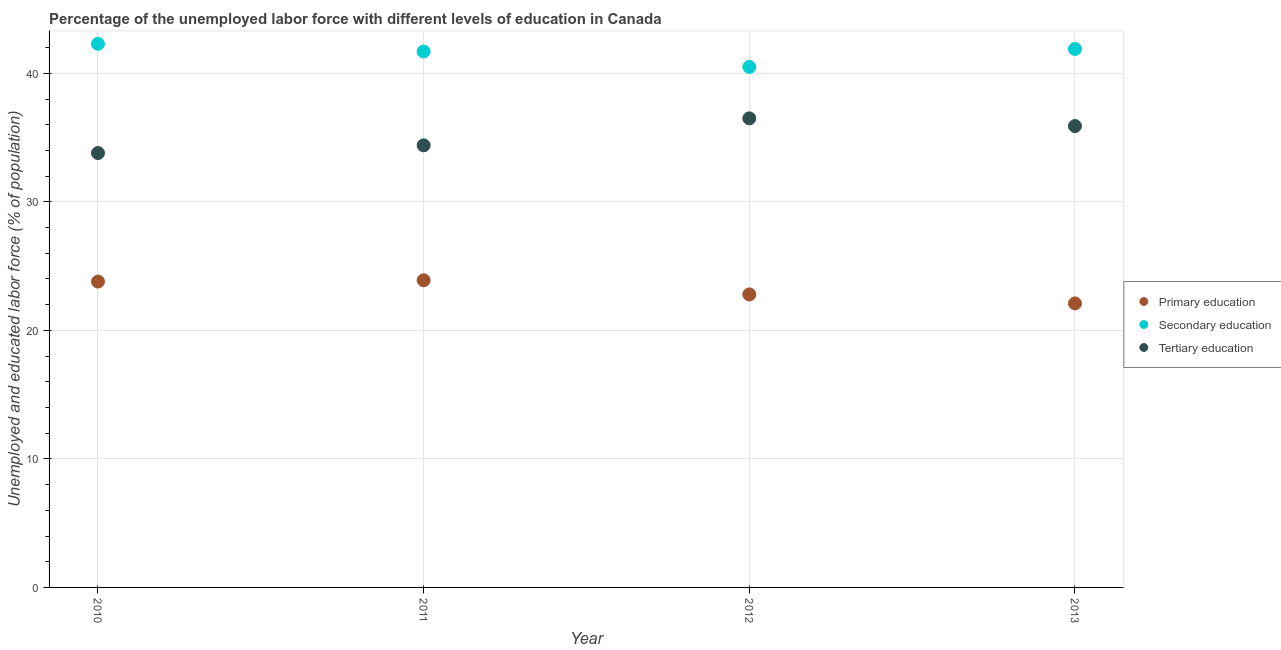What is the percentage of labor force who received secondary education in 2011?
Your response must be concise. 41.7. Across all years, what is the maximum percentage of labor force who received tertiary education?
Make the answer very short. 36.5. Across all years, what is the minimum percentage of labor force who received tertiary education?
Give a very brief answer. 33.8. In which year was the percentage of labor force who received primary education minimum?
Give a very brief answer. 2013. What is the total percentage of labor force who received tertiary education in the graph?
Provide a succinct answer. 140.6. What is the difference between the percentage of labor force who received tertiary education in 2011 and that in 2013?
Provide a short and direct response. -1.5. What is the difference between the percentage of labor force who received tertiary education in 2011 and the percentage of labor force who received primary education in 2013?
Ensure brevity in your answer.  12.3. What is the average percentage of labor force who received primary education per year?
Your answer should be very brief. 23.15. In the year 2011, what is the difference between the percentage of labor force who received secondary education and percentage of labor force who received tertiary education?
Give a very brief answer. 7.3. What is the ratio of the percentage of labor force who received secondary education in 2011 to that in 2013?
Give a very brief answer. 1. Is the percentage of labor force who received tertiary education in 2011 less than that in 2013?
Ensure brevity in your answer.  Yes. What is the difference between the highest and the second highest percentage of labor force who received secondary education?
Your answer should be compact. 0.4. What is the difference between the highest and the lowest percentage of labor force who received primary education?
Keep it short and to the point. 1.8. In how many years, is the percentage of labor force who received secondary education greater than the average percentage of labor force who received secondary education taken over all years?
Your response must be concise. 3. Is the percentage of labor force who received secondary education strictly greater than the percentage of labor force who received tertiary education over the years?
Keep it short and to the point. Yes. Is the percentage of labor force who received tertiary education strictly less than the percentage of labor force who received primary education over the years?
Provide a succinct answer. No. Does the graph contain grids?
Your answer should be very brief. Yes. Where does the legend appear in the graph?
Offer a very short reply. Center right. How many legend labels are there?
Your answer should be compact. 3. What is the title of the graph?
Offer a very short reply. Percentage of the unemployed labor force with different levels of education in Canada. Does "Capital account" appear as one of the legend labels in the graph?
Your answer should be compact. No. What is the label or title of the Y-axis?
Provide a succinct answer. Unemployed and educated labor force (% of population). What is the Unemployed and educated labor force (% of population) in Primary education in 2010?
Your answer should be compact. 23.8. What is the Unemployed and educated labor force (% of population) in Secondary education in 2010?
Your answer should be compact. 42.3. What is the Unemployed and educated labor force (% of population) in Tertiary education in 2010?
Provide a short and direct response. 33.8. What is the Unemployed and educated labor force (% of population) of Primary education in 2011?
Provide a succinct answer. 23.9. What is the Unemployed and educated labor force (% of population) of Secondary education in 2011?
Your answer should be compact. 41.7. What is the Unemployed and educated labor force (% of population) in Tertiary education in 2011?
Provide a short and direct response. 34.4. What is the Unemployed and educated labor force (% of population) in Primary education in 2012?
Offer a terse response. 22.8. What is the Unemployed and educated labor force (% of population) of Secondary education in 2012?
Ensure brevity in your answer.  40.5. What is the Unemployed and educated labor force (% of population) in Tertiary education in 2012?
Your answer should be compact. 36.5. What is the Unemployed and educated labor force (% of population) in Primary education in 2013?
Keep it short and to the point. 22.1. What is the Unemployed and educated labor force (% of population) in Secondary education in 2013?
Make the answer very short. 41.9. What is the Unemployed and educated labor force (% of population) of Tertiary education in 2013?
Provide a short and direct response. 35.9. Across all years, what is the maximum Unemployed and educated labor force (% of population) in Primary education?
Offer a terse response. 23.9. Across all years, what is the maximum Unemployed and educated labor force (% of population) of Secondary education?
Your response must be concise. 42.3. Across all years, what is the maximum Unemployed and educated labor force (% of population) in Tertiary education?
Keep it short and to the point. 36.5. Across all years, what is the minimum Unemployed and educated labor force (% of population) of Primary education?
Your response must be concise. 22.1. Across all years, what is the minimum Unemployed and educated labor force (% of population) of Secondary education?
Offer a terse response. 40.5. Across all years, what is the minimum Unemployed and educated labor force (% of population) of Tertiary education?
Offer a very short reply. 33.8. What is the total Unemployed and educated labor force (% of population) of Primary education in the graph?
Give a very brief answer. 92.6. What is the total Unemployed and educated labor force (% of population) in Secondary education in the graph?
Give a very brief answer. 166.4. What is the total Unemployed and educated labor force (% of population) of Tertiary education in the graph?
Your response must be concise. 140.6. What is the difference between the Unemployed and educated labor force (% of population) of Primary education in 2010 and that in 2011?
Your answer should be very brief. -0.1. What is the difference between the Unemployed and educated labor force (% of population) in Secondary education in 2010 and that in 2011?
Offer a very short reply. 0.6. What is the difference between the Unemployed and educated labor force (% of population) in Primary education in 2010 and that in 2012?
Your answer should be very brief. 1. What is the difference between the Unemployed and educated labor force (% of population) of Secondary education in 2010 and that in 2012?
Keep it short and to the point. 1.8. What is the difference between the Unemployed and educated labor force (% of population) in Primary education in 2010 and that in 2013?
Offer a very short reply. 1.7. What is the difference between the Unemployed and educated labor force (% of population) of Secondary education in 2010 and that in 2013?
Your answer should be compact. 0.4. What is the difference between the Unemployed and educated labor force (% of population) in Tertiary education in 2010 and that in 2013?
Provide a succinct answer. -2.1. What is the difference between the Unemployed and educated labor force (% of population) of Primary education in 2011 and that in 2012?
Make the answer very short. 1.1. What is the difference between the Unemployed and educated labor force (% of population) in Tertiary education in 2011 and that in 2012?
Provide a short and direct response. -2.1. What is the difference between the Unemployed and educated labor force (% of population) in Tertiary education in 2011 and that in 2013?
Provide a succinct answer. -1.5. What is the difference between the Unemployed and educated labor force (% of population) of Primary education in 2012 and that in 2013?
Make the answer very short. 0.7. What is the difference between the Unemployed and educated labor force (% of population) in Secondary education in 2012 and that in 2013?
Your response must be concise. -1.4. What is the difference between the Unemployed and educated labor force (% of population) of Tertiary education in 2012 and that in 2013?
Ensure brevity in your answer.  0.6. What is the difference between the Unemployed and educated labor force (% of population) in Primary education in 2010 and the Unemployed and educated labor force (% of population) in Secondary education in 2011?
Ensure brevity in your answer.  -17.9. What is the difference between the Unemployed and educated labor force (% of population) of Primary education in 2010 and the Unemployed and educated labor force (% of population) of Tertiary education in 2011?
Your answer should be compact. -10.6. What is the difference between the Unemployed and educated labor force (% of population) in Secondary education in 2010 and the Unemployed and educated labor force (% of population) in Tertiary education in 2011?
Make the answer very short. 7.9. What is the difference between the Unemployed and educated labor force (% of population) of Primary education in 2010 and the Unemployed and educated labor force (% of population) of Secondary education in 2012?
Offer a terse response. -16.7. What is the difference between the Unemployed and educated labor force (% of population) of Primary education in 2010 and the Unemployed and educated labor force (% of population) of Tertiary education in 2012?
Offer a terse response. -12.7. What is the difference between the Unemployed and educated labor force (% of population) of Secondary education in 2010 and the Unemployed and educated labor force (% of population) of Tertiary education in 2012?
Make the answer very short. 5.8. What is the difference between the Unemployed and educated labor force (% of population) of Primary education in 2010 and the Unemployed and educated labor force (% of population) of Secondary education in 2013?
Give a very brief answer. -18.1. What is the difference between the Unemployed and educated labor force (% of population) of Secondary education in 2010 and the Unemployed and educated labor force (% of population) of Tertiary education in 2013?
Offer a terse response. 6.4. What is the difference between the Unemployed and educated labor force (% of population) in Primary education in 2011 and the Unemployed and educated labor force (% of population) in Secondary education in 2012?
Provide a short and direct response. -16.6. What is the difference between the Unemployed and educated labor force (% of population) of Primary education in 2011 and the Unemployed and educated labor force (% of population) of Tertiary education in 2013?
Give a very brief answer. -12. What is the difference between the Unemployed and educated labor force (% of population) of Primary education in 2012 and the Unemployed and educated labor force (% of population) of Secondary education in 2013?
Offer a very short reply. -19.1. What is the average Unemployed and educated labor force (% of population) of Primary education per year?
Offer a terse response. 23.15. What is the average Unemployed and educated labor force (% of population) in Secondary education per year?
Provide a succinct answer. 41.6. What is the average Unemployed and educated labor force (% of population) of Tertiary education per year?
Ensure brevity in your answer.  35.15. In the year 2010, what is the difference between the Unemployed and educated labor force (% of population) in Primary education and Unemployed and educated labor force (% of population) in Secondary education?
Provide a short and direct response. -18.5. In the year 2011, what is the difference between the Unemployed and educated labor force (% of population) in Primary education and Unemployed and educated labor force (% of population) in Secondary education?
Provide a succinct answer. -17.8. In the year 2012, what is the difference between the Unemployed and educated labor force (% of population) in Primary education and Unemployed and educated labor force (% of population) in Secondary education?
Offer a terse response. -17.7. In the year 2012, what is the difference between the Unemployed and educated labor force (% of population) in Primary education and Unemployed and educated labor force (% of population) in Tertiary education?
Provide a short and direct response. -13.7. In the year 2013, what is the difference between the Unemployed and educated labor force (% of population) of Primary education and Unemployed and educated labor force (% of population) of Secondary education?
Keep it short and to the point. -19.8. In the year 2013, what is the difference between the Unemployed and educated labor force (% of population) of Secondary education and Unemployed and educated labor force (% of population) of Tertiary education?
Provide a succinct answer. 6. What is the ratio of the Unemployed and educated labor force (% of population) of Primary education in 2010 to that in 2011?
Your response must be concise. 1. What is the ratio of the Unemployed and educated labor force (% of population) in Secondary education in 2010 to that in 2011?
Your response must be concise. 1.01. What is the ratio of the Unemployed and educated labor force (% of population) in Tertiary education in 2010 to that in 2011?
Make the answer very short. 0.98. What is the ratio of the Unemployed and educated labor force (% of population) of Primary education in 2010 to that in 2012?
Provide a short and direct response. 1.04. What is the ratio of the Unemployed and educated labor force (% of population) of Secondary education in 2010 to that in 2012?
Keep it short and to the point. 1.04. What is the ratio of the Unemployed and educated labor force (% of population) in Tertiary education in 2010 to that in 2012?
Your response must be concise. 0.93. What is the ratio of the Unemployed and educated labor force (% of population) in Secondary education in 2010 to that in 2013?
Your answer should be very brief. 1.01. What is the ratio of the Unemployed and educated labor force (% of population) in Tertiary education in 2010 to that in 2013?
Ensure brevity in your answer.  0.94. What is the ratio of the Unemployed and educated labor force (% of population) of Primary education in 2011 to that in 2012?
Your response must be concise. 1.05. What is the ratio of the Unemployed and educated labor force (% of population) of Secondary education in 2011 to that in 2012?
Your response must be concise. 1.03. What is the ratio of the Unemployed and educated labor force (% of population) in Tertiary education in 2011 to that in 2012?
Ensure brevity in your answer.  0.94. What is the ratio of the Unemployed and educated labor force (% of population) in Primary education in 2011 to that in 2013?
Make the answer very short. 1.08. What is the ratio of the Unemployed and educated labor force (% of population) of Secondary education in 2011 to that in 2013?
Offer a terse response. 1. What is the ratio of the Unemployed and educated labor force (% of population) of Tertiary education in 2011 to that in 2013?
Make the answer very short. 0.96. What is the ratio of the Unemployed and educated labor force (% of population) in Primary education in 2012 to that in 2013?
Your answer should be very brief. 1.03. What is the ratio of the Unemployed and educated labor force (% of population) of Secondary education in 2012 to that in 2013?
Keep it short and to the point. 0.97. What is the ratio of the Unemployed and educated labor force (% of population) in Tertiary education in 2012 to that in 2013?
Make the answer very short. 1.02. What is the difference between the highest and the second highest Unemployed and educated labor force (% of population) in Primary education?
Ensure brevity in your answer.  0.1. What is the difference between the highest and the second highest Unemployed and educated labor force (% of population) in Secondary education?
Make the answer very short. 0.4. What is the difference between the highest and the second highest Unemployed and educated labor force (% of population) of Tertiary education?
Your response must be concise. 0.6. What is the difference between the highest and the lowest Unemployed and educated labor force (% of population) of Secondary education?
Give a very brief answer. 1.8. What is the difference between the highest and the lowest Unemployed and educated labor force (% of population) of Tertiary education?
Offer a terse response. 2.7. 